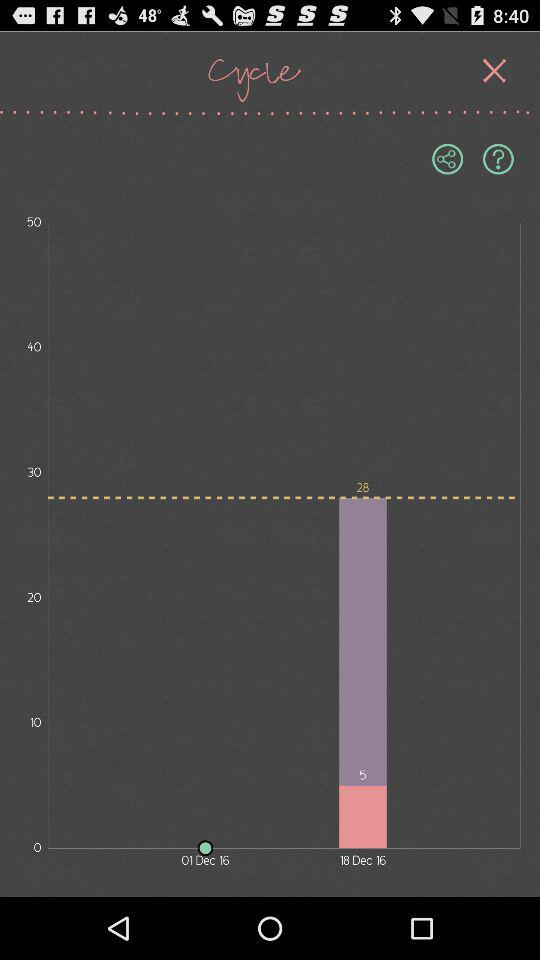What is the period date? The period date is December 18. 